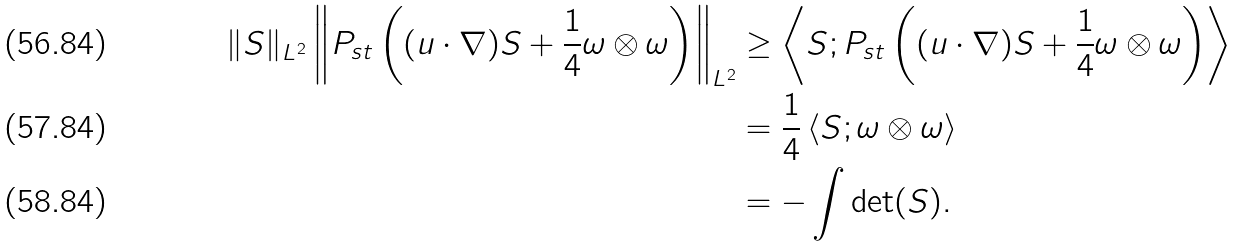Convert formula to latex. <formula><loc_0><loc_0><loc_500><loc_500>\| S \| _ { L ^ { 2 } } \left \| P _ { s t } \left ( ( u \cdot \nabla ) S + \frac { 1 } { 4 } \omega \otimes \omega \right ) \right \| _ { L ^ { 2 } } & \geq \left < S ; P _ { s t } \left ( ( u \cdot \nabla ) S + \frac { 1 } { 4 } \omega \otimes \omega \right ) \right > \\ & = \frac { 1 } { 4 } \left < S ; \omega \otimes \omega \right > \\ & = - \int \det ( S ) .</formula> 